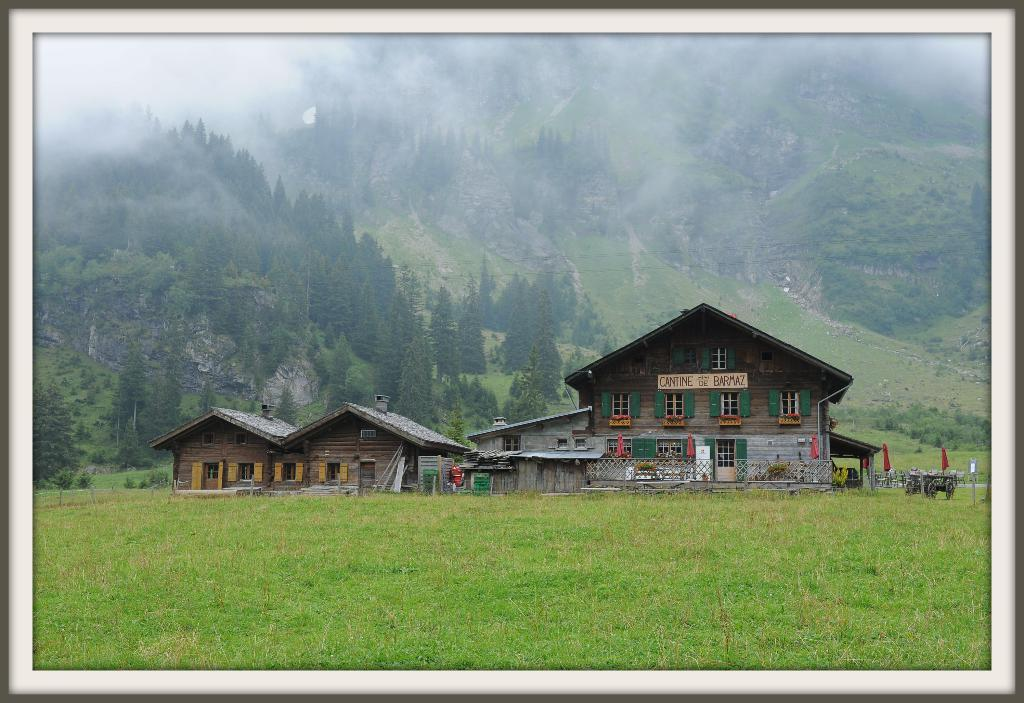What type of structure is visible in the image? There is a building in the image. What is covering the floor in the image? There is grass on the floor in the image. What can be seen in the distance in the image? There are mountains in the background of the image. How are the mountains in the image characterized? The mountains are covered with trees. What type of book is being used in the operation depicted in the image? There is no book or operation present in the image; it features a building, grass, mountains, and trees. 